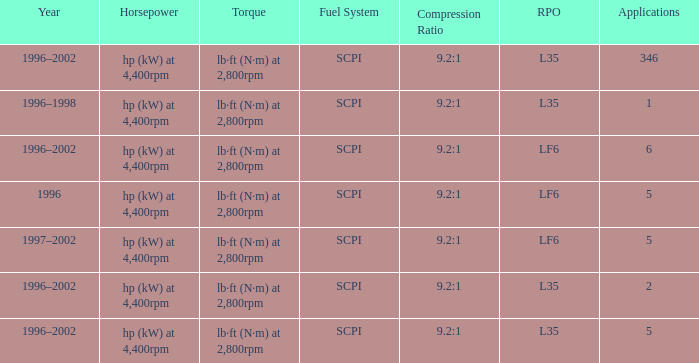What are the torque characteristics of the model made in 1996? Lb·ft (n·m) at 2,800rpm. 